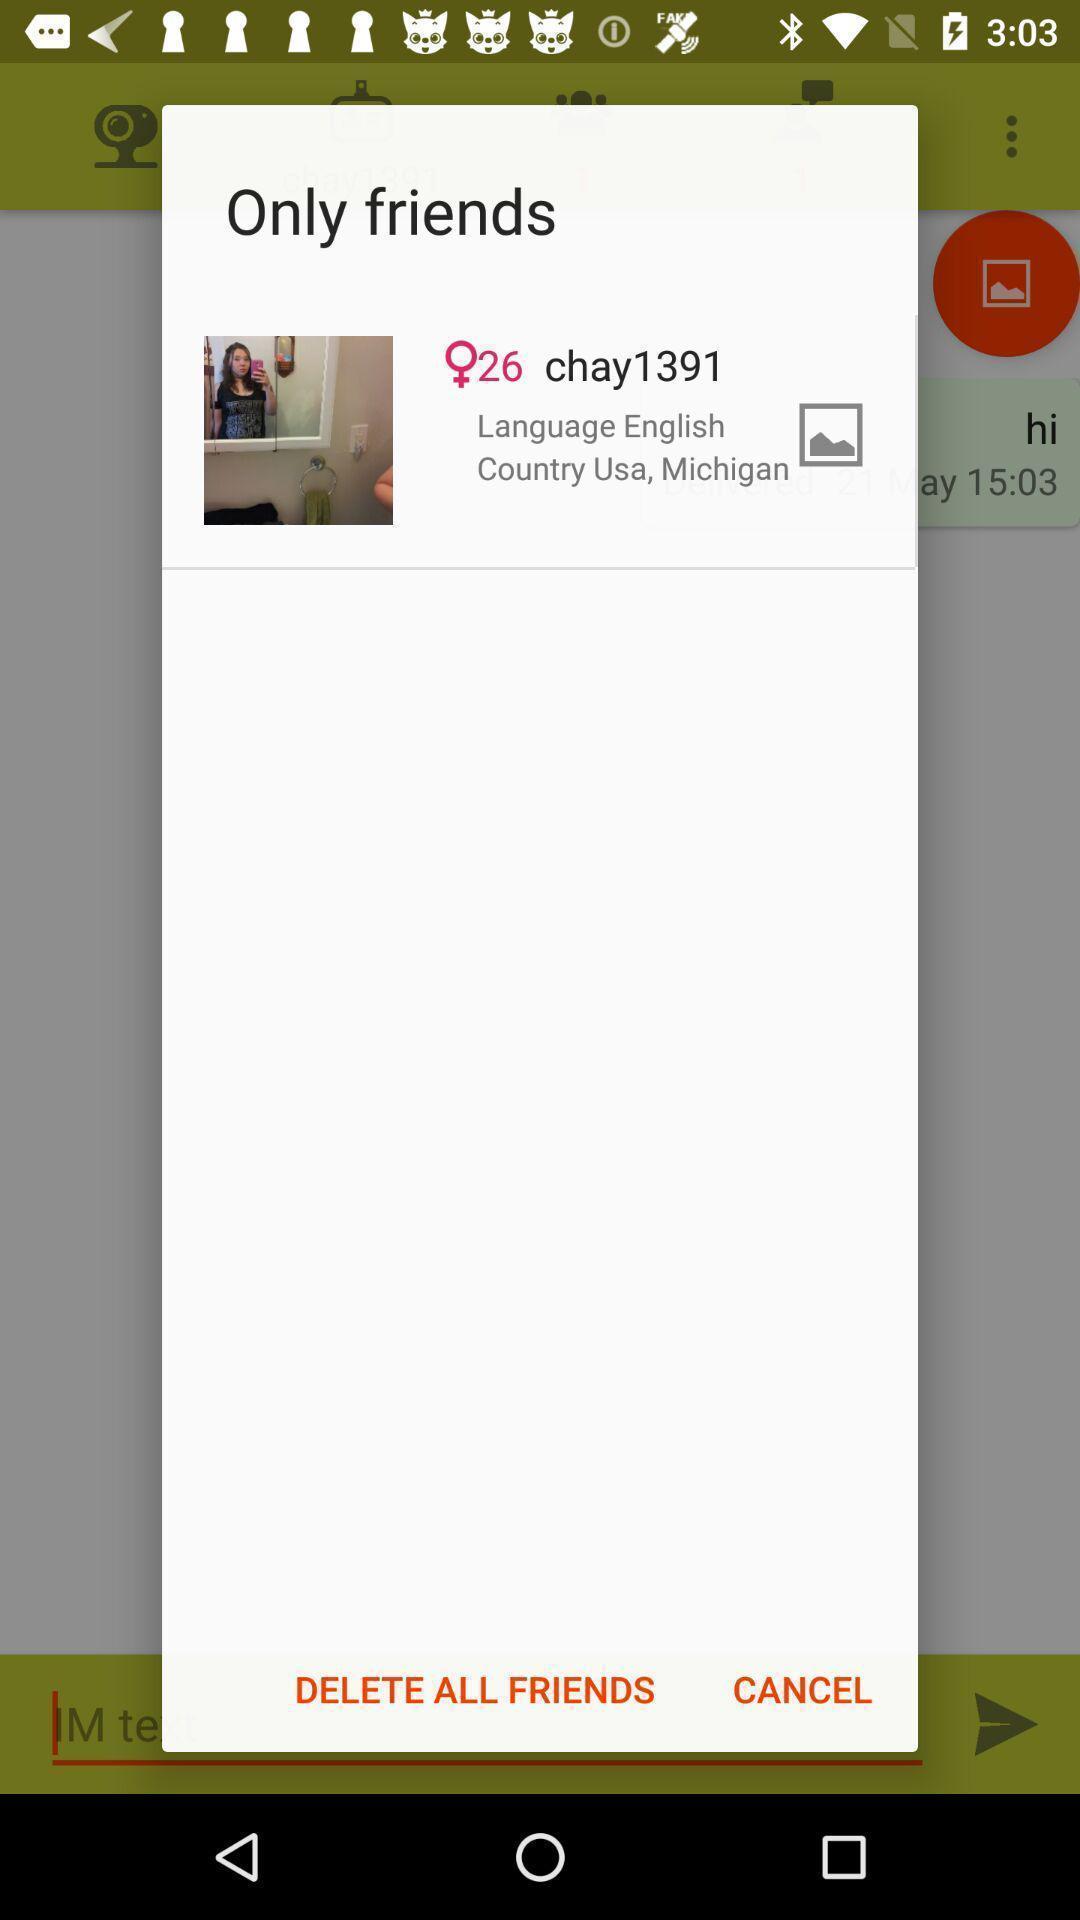Provide a textual representation of this image. Pop-up showing only friends in a social media app. 